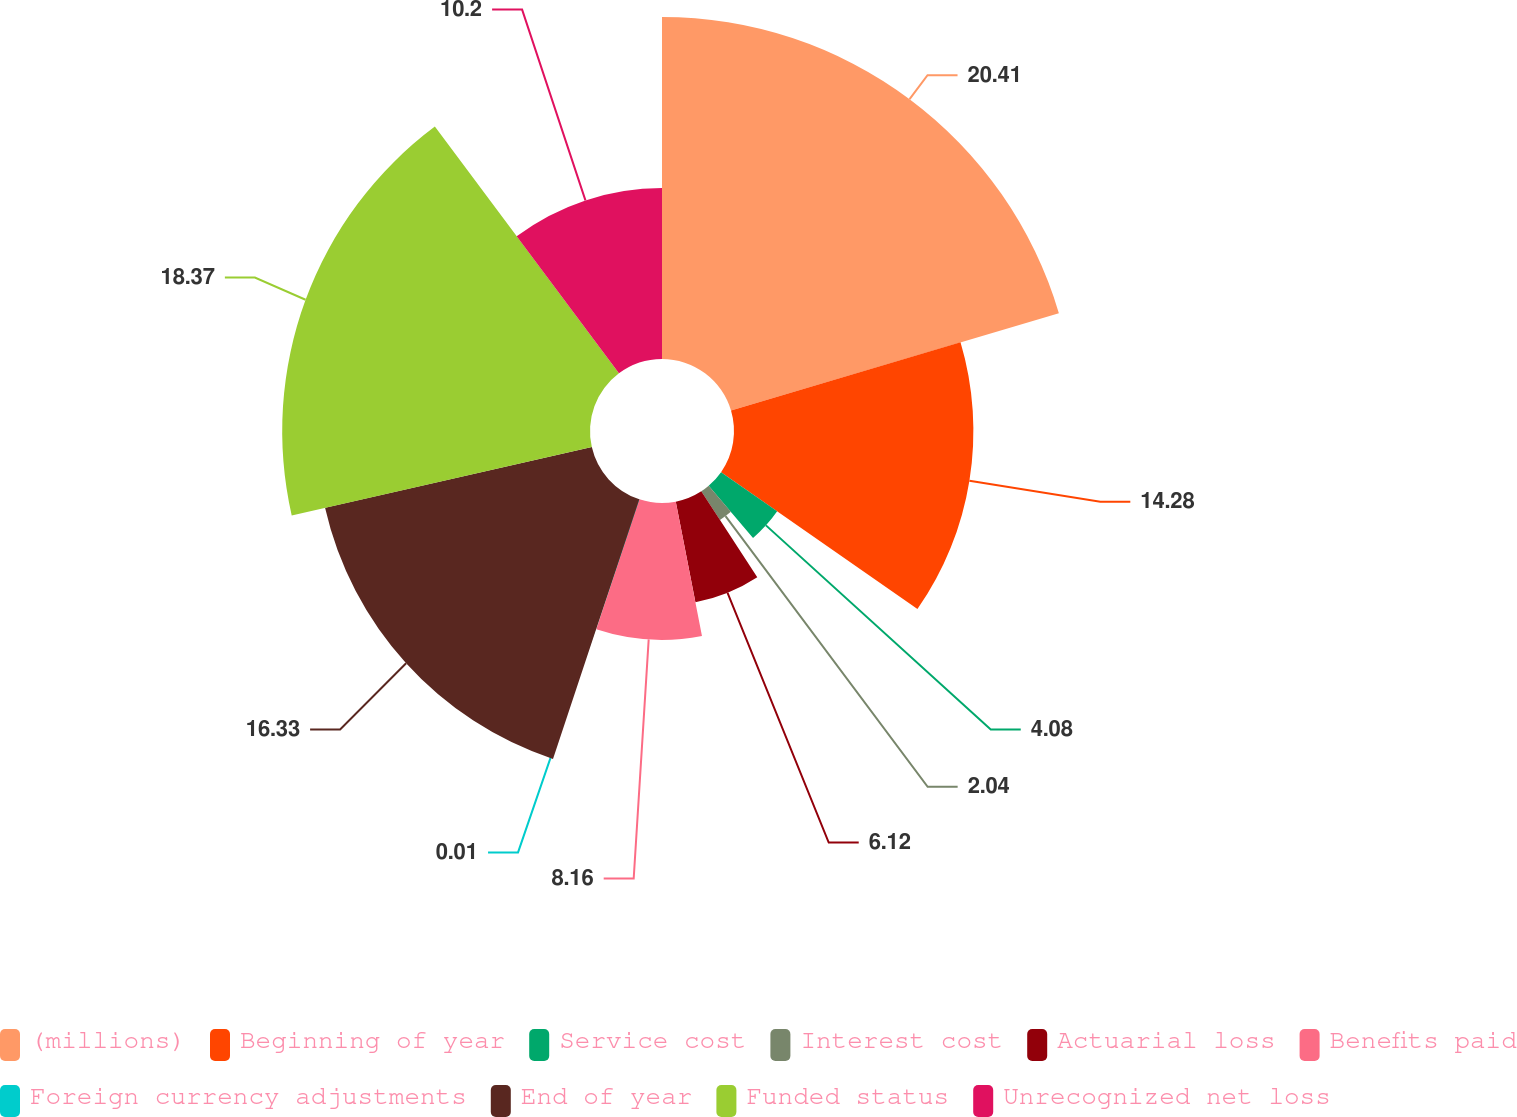<chart> <loc_0><loc_0><loc_500><loc_500><pie_chart><fcel>(millions)<fcel>Beginning of year<fcel>Service cost<fcel>Interest cost<fcel>Actuarial loss<fcel>Benefits paid<fcel>Foreign currency adjustments<fcel>End of year<fcel>Funded status<fcel>Unrecognized net loss<nl><fcel>20.4%<fcel>14.28%<fcel>4.08%<fcel>2.04%<fcel>6.12%<fcel>8.16%<fcel>0.01%<fcel>16.32%<fcel>18.36%<fcel>10.2%<nl></chart> 